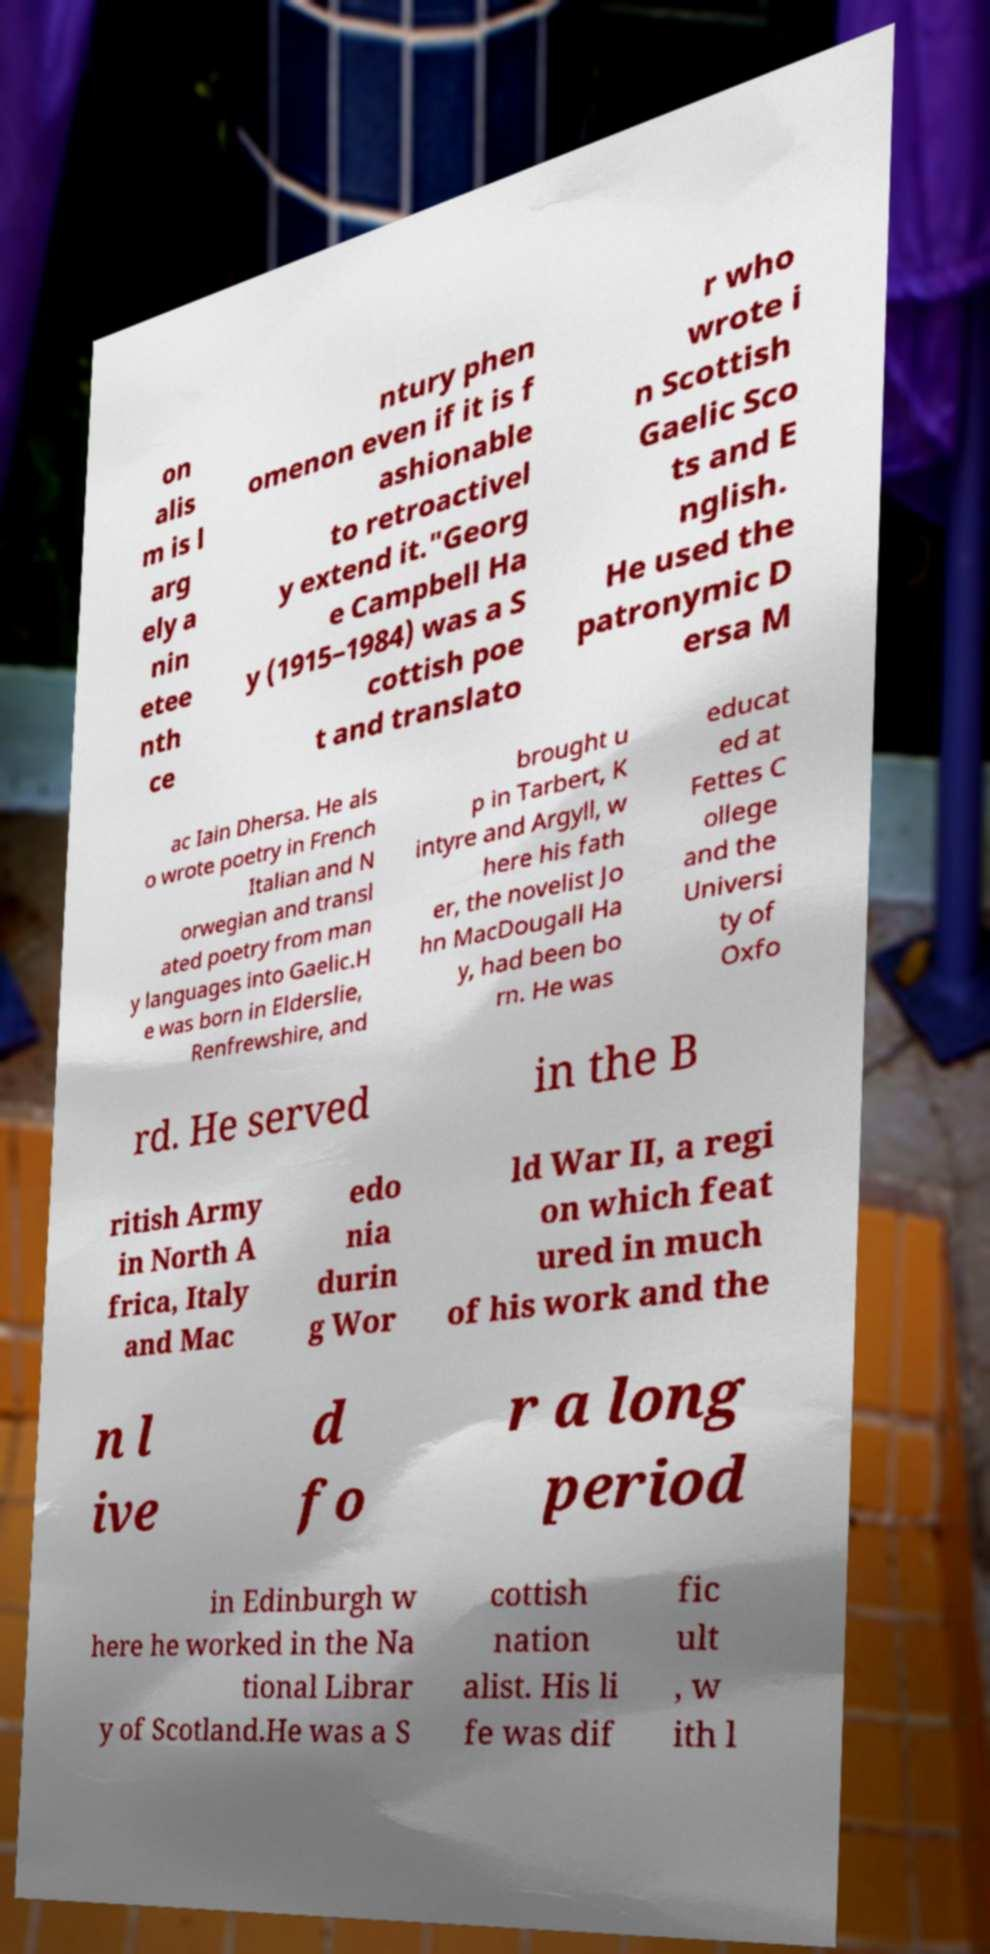Please identify and transcribe the text found in this image. on alis m is l arg ely a nin etee nth ce ntury phen omenon even if it is f ashionable to retroactivel y extend it."Georg e Campbell Ha y (1915–1984) was a S cottish poe t and translato r who wrote i n Scottish Gaelic Sco ts and E nglish. He used the patronymic D ersa M ac Iain Dhersa. He als o wrote poetry in French Italian and N orwegian and transl ated poetry from man y languages into Gaelic.H e was born in Elderslie, Renfrewshire, and brought u p in Tarbert, K intyre and Argyll, w here his fath er, the novelist Jo hn MacDougall Ha y, had been bo rn. He was educat ed at Fettes C ollege and the Universi ty of Oxfo rd. He served in the B ritish Army in North A frica, Italy and Mac edo nia durin g Wor ld War II, a regi on which feat ured in much of his work and the n l ive d fo r a long period in Edinburgh w here he worked in the Na tional Librar y of Scotland.He was a S cottish nation alist. His li fe was dif fic ult , w ith l 